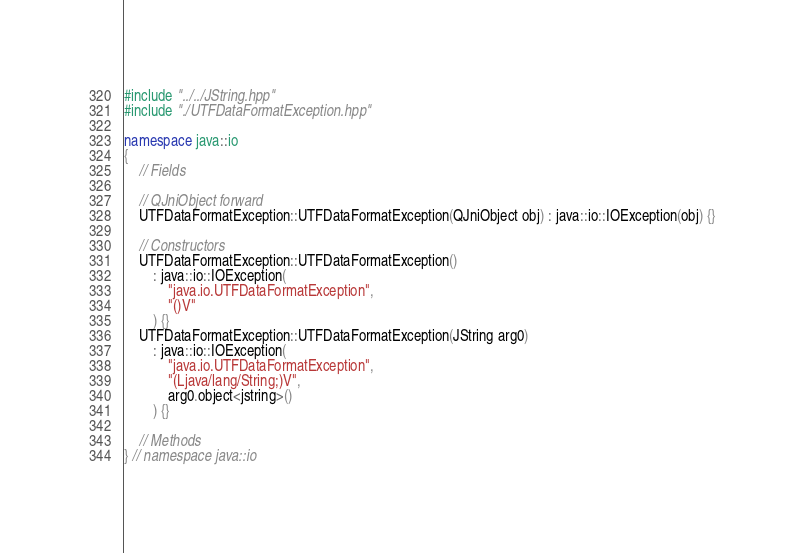Convert code to text. <code><loc_0><loc_0><loc_500><loc_500><_C++_>#include "../../JString.hpp"
#include "./UTFDataFormatException.hpp"

namespace java::io
{
	// Fields
	
	// QJniObject forward
	UTFDataFormatException::UTFDataFormatException(QJniObject obj) : java::io::IOException(obj) {}
	
	// Constructors
	UTFDataFormatException::UTFDataFormatException()
		: java::io::IOException(
			"java.io.UTFDataFormatException",
			"()V"
		) {}
	UTFDataFormatException::UTFDataFormatException(JString arg0)
		: java::io::IOException(
			"java.io.UTFDataFormatException",
			"(Ljava/lang/String;)V",
			arg0.object<jstring>()
		) {}
	
	// Methods
} // namespace java::io

</code> 